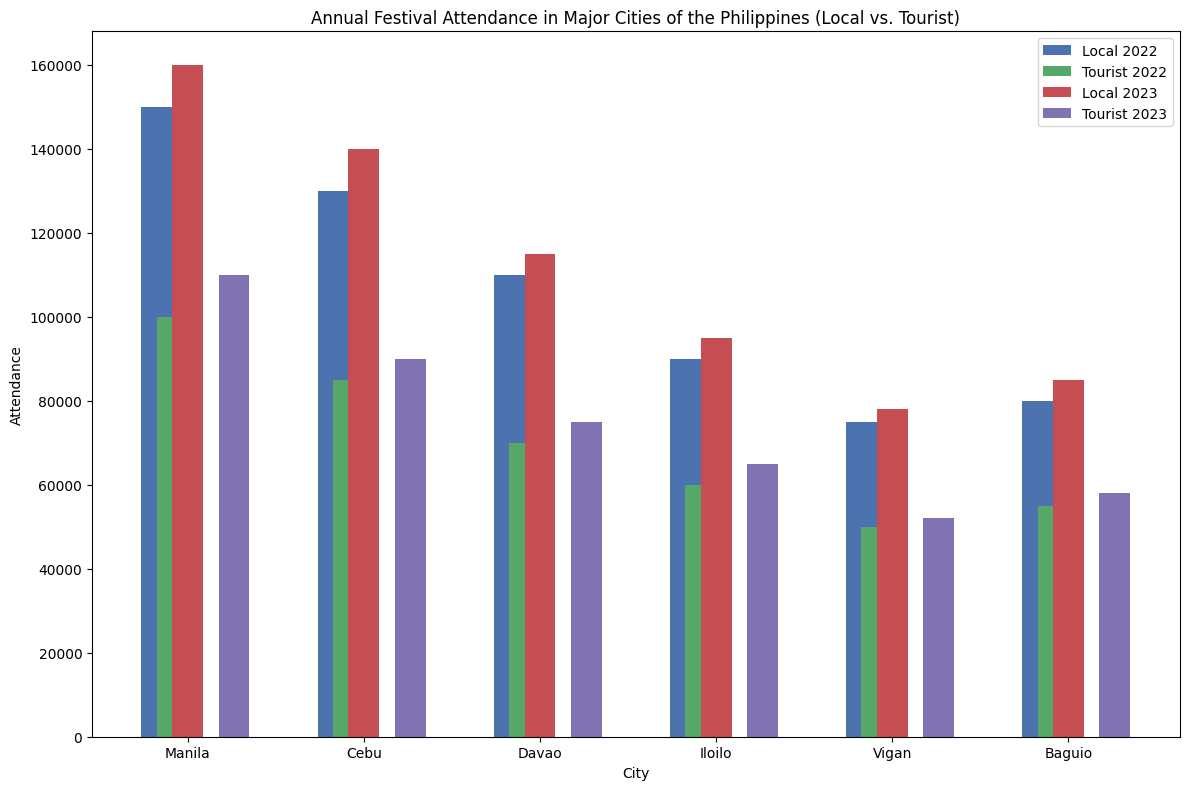Which city had the highest total attendance in 2022? Look at both local and tourist bars for each city in 2022, sum them up. Manila has 150,000 (Local) + 100,000 (Tourist) = 250,000, Cebu has 130,000 (Local) + 85,000 (Tourist) = 215,000, and so on. We see Manila has the highest total attendance.
Answer: Manila Which city had the least tourist attendance in 2023? Compare the tourist attendance bars for each city in 2023. Iloilo has the lowest tourist attendance with 65,000.
Answer: Iloilo How did local attendance in Cebu change from 2022 to 2023? Subtract the local attendance in 2022 from 2023 for Cebu: 140,000 (2023) - 130,000 (2022) = 10,000.
Answer: Increased by 10,000 Which city had the smallest difference between local and tourist attendance in 2022? Calculate the difference for each city in 2022: Manila (50,000), Cebu (45,000), Davao (40,000), Iloilo (30,000), Vigan (25,000), Baguio (25,000). Both Vigan and Baguio have the smallest difference of 25,000.
Answer: Vigan and Baguio Did any city's local attendance decrease from 2022 to 2023? Compare local attendance bars for each city between 2022 and 2023. No city's local attendance decreased.
Answer: No What is the total tourist attendance across all cities in 2022? Sum the tourist attendance for all cities in 2022: 100,000 + 85,000 + 70,000 + 60,000 + 50,000 + 55,000 = 420,000.
Answer: 420,000 In which city were local visitors more than double the number of tourist visitors in 2022? Check if any city's local attendance is more than twice their tourist attendance: Manila (150,000 vs. 100,000), Cebu (130,000 vs. 85,000), Davao (110,000 vs. 70,000), Iloilo (90,000 vs. 60,000), Vigan (75,000 vs. 50,000), Baguio (80,000 vs. 55,000). No city meets this criteria.
Answer: None Which year had higher total attendance in Manila, 2022 or 2023? Total attendance for 2022 is 150,000 (Local) + 100,000 (Tourist) = 250,000. Total attendance for 2023 is 160,000 (Local) + 110,000 (Tourist) = 270,000. So, the year 2023 had a higher total attendance.
Answer: 2023 What is the difference in total tourist attendance between 2022 and 2023 in Davao? Tourist attendance in Davao is 70,000 (2022) and 75,000 (2023). The difference is 75,000 - 70,000 = 5,000.
Answer: 5,000 